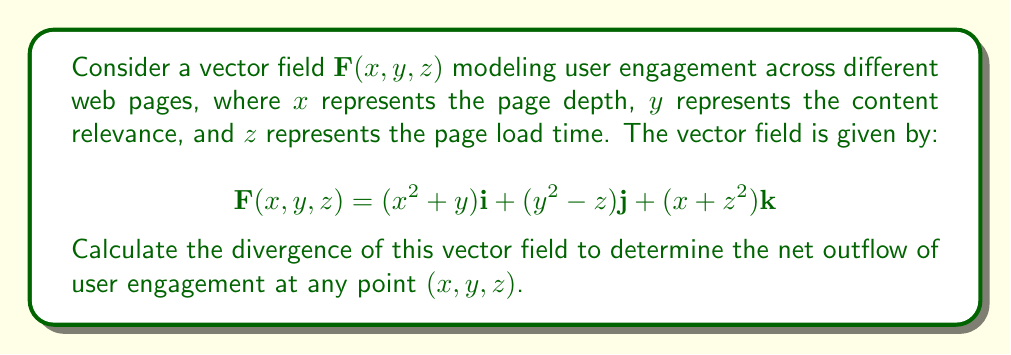Provide a solution to this math problem. To calculate the divergence of the vector field $\mathbf{F}(x, y, z)$, we need to find the sum of the partial derivatives of each component with respect to its corresponding variable. The divergence is given by:

$$\text{div}\mathbf{F} = \nabla \cdot \mathbf{F} = \frac{\partial F_x}{\partial x} + \frac{\partial F_y}{\partial y} + \frac{\partial F_z}{\partial z}$$

Let's calculate each partial derivative:

1. $\frac{\partial F_x}{\partial x}$:
   $F_x = x^2 + y$
   $\frac{\partial F_x}{\partial x} = 2x$

2. $\frac{\partial F_y}{\partial y}$:
   $F_y = y^2 - z$
   $\frac{\partial F_y}{\partial y} = 2y$

3. $\frac{\partial F_z}{\partial z}$:
   $F_z = x + z^2$
   $\frac{\partial F_z}{\partial z} = 2z$

Now, we sum these partial derivatives:

$$\text{div}\mathbf{F} = \frac{\partial F_x}{\partial x} + \frac{\partial F_y}{\partial y} + \frac{\partial F_z}{\partial z}$$
$$\text{div}\mathbf{F} = 2x + 2y + 2z$$

This expression represents the divergence of the vector field $\mathbf{F}(x, y, z)$ at any point $(x, y, z)$.
Answer: $2x + 2y + 2z$ 